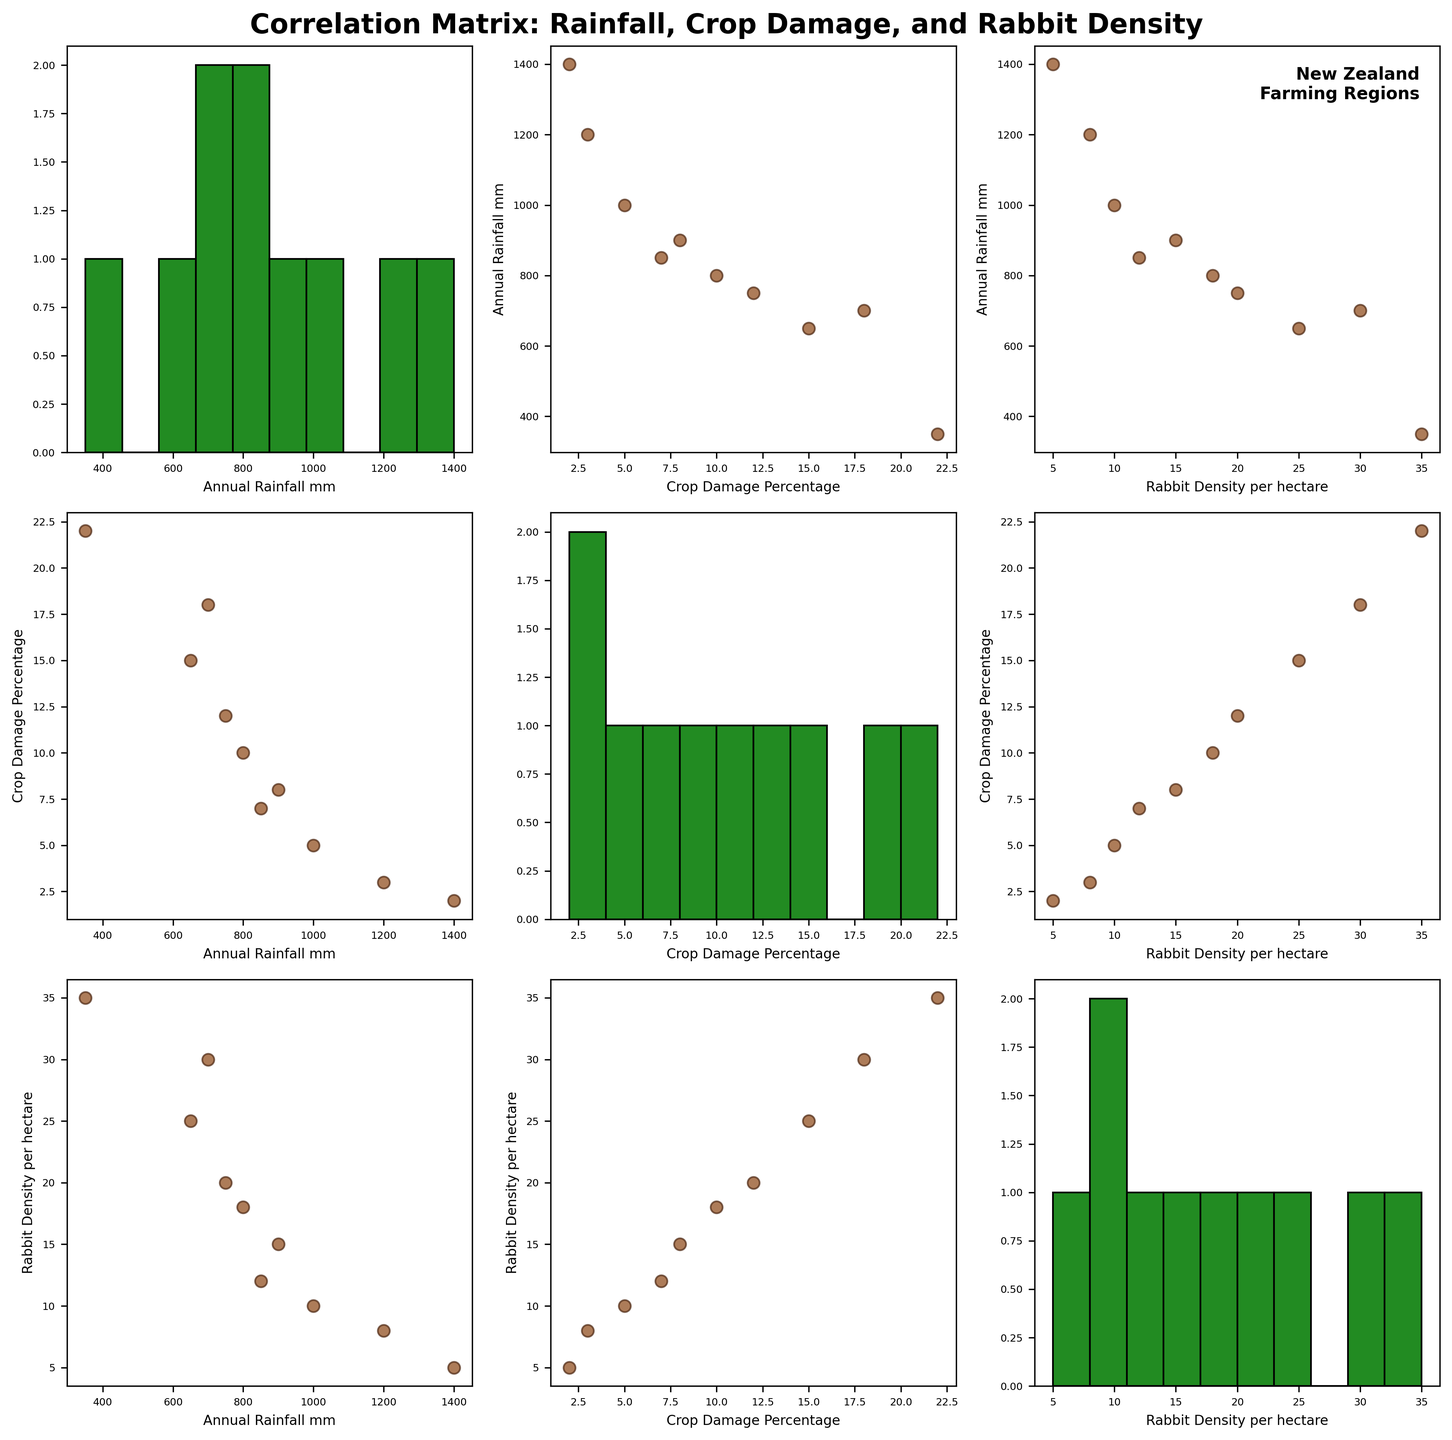Which region has the highest rabbit density per hectare? By observing the scatter plots and identifying the point that represents the highest density on the y-axis of the "Rabbit Density per hectare" vs. "Region" plot, we can determine the corresponding region. The point with the highest value corresponds to Central Otago.
Answer: Central Otago What is the overall trend between annual rainfall and crop damage percentage? Examining the scatter plot between "Annual Rainfall mm" and "Crop Damage Percentage," we look for patterns. The general trend appears to show that higher annual rainfall correlates with lower crop damage percentages. Higher rainfall regions like Waikato and Bay of Plenty show lower crop damage percentages compared to lower rainfall regions like Central Otago and Canterbury.
Answer: Negative correlation How many regions have an annual rainfall greater than 1000 mm? Look at the histogram or scatter plot involving "Annual Rainfall mm." Identify how many data points fall to the right of the 1000 mm mark on the x-axis. The regions Waikato and Bay of Plenty have annual rainfall greater than 1000 mm.
Answer: 2 Which two regions have the closest rabbit densities? By comparing the data points in the scatter plot involving "Rabbit Density per hectare," identify two regions with very close values on the y-axis. Otago (20 rabbits per hectare) and Hawke's Bay (18 rabbits per hectare) have the closest rabbit densities.
Answer: Otago, Hawke's Bay In which region is the crop damage percentage the lowest, and what is its value? By observing the scatter plot of "Crop Damage Percentage" against regions, find the lowest point on the y-axis. Waikato has the lowest crop damage percentage value, which is 2%.
Answer: Waikato, 2% How does crop damage percentage change with rabbit density? By looking at the scatter plot between "Rabbit Density per hectare" and "Crop Damage Percentage," we see that higher rabbit densities generally correspond to higher crop damage percentages. As rabbit density increases from left to right, crop damage percentage also increases.
Answer: Positive correlation Which region has the highest annual rainfall, and what is its value? By examining the histogram or scatter plots involving "Annual Rainfall mm," find the highest point on the x-axis. Bay of Plenty has the highest annual rainfall value, which is 1400 mm.
Answer: Bay of Plenty, 1400 mm Is there a region with both low rainfall and high crop damage? By looking at the scatter plot between "Annual Rainfall mm" and "Crop Damage Percentage," identify a point with low rainfall on the x-axis and high crop damage on the y-axis. Central Otago is the region with low rainfall (350 mm) and high crop damage percentage (22%).
Answer: Central Otago Which region has the second lowest crop damage percentage? Observing the scatter plot of "Crop Damage Percentage," identify the second lowest data point. Bay of Plenty, with a crop damage percentage of 2%, is the lowest, followed by Waikato at 3%. So, Waikato has the second lowest crop damage percentage.
Answer: Waikato 